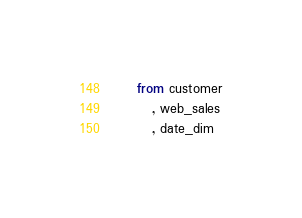Convert code to text. <code><loc_0><loc_0><loc_500><loc_500><_SQL_>    from customer
       , web_sales
       , date_dim</code> 